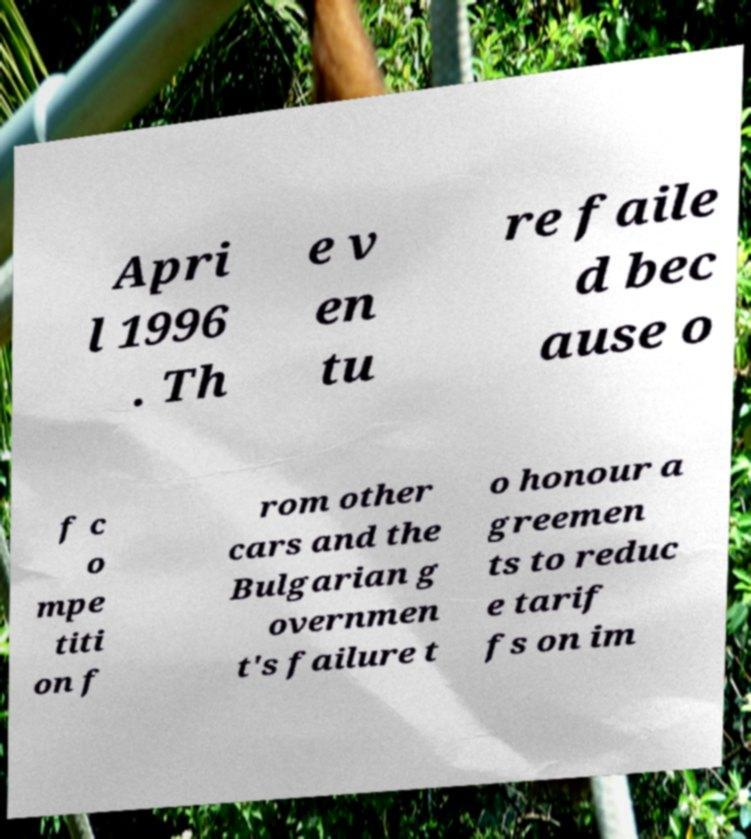For documentation purposes, I need the text within this image transcribed. Could you provide that? Apri l 1996 . Th e v en tu re faile d bec ause o f c o mpe titi on f rom other cars and the Bulgarian g overnmen t's failure t o honour a greemen ts to reduc e tarif fs on im 